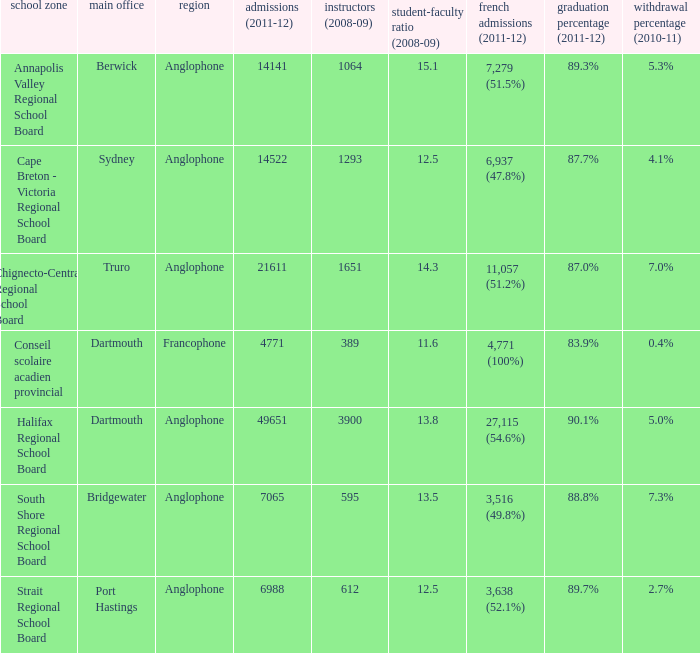Where is the headquarter located for the Annapolis Valley Regional School Board? Berwick. 